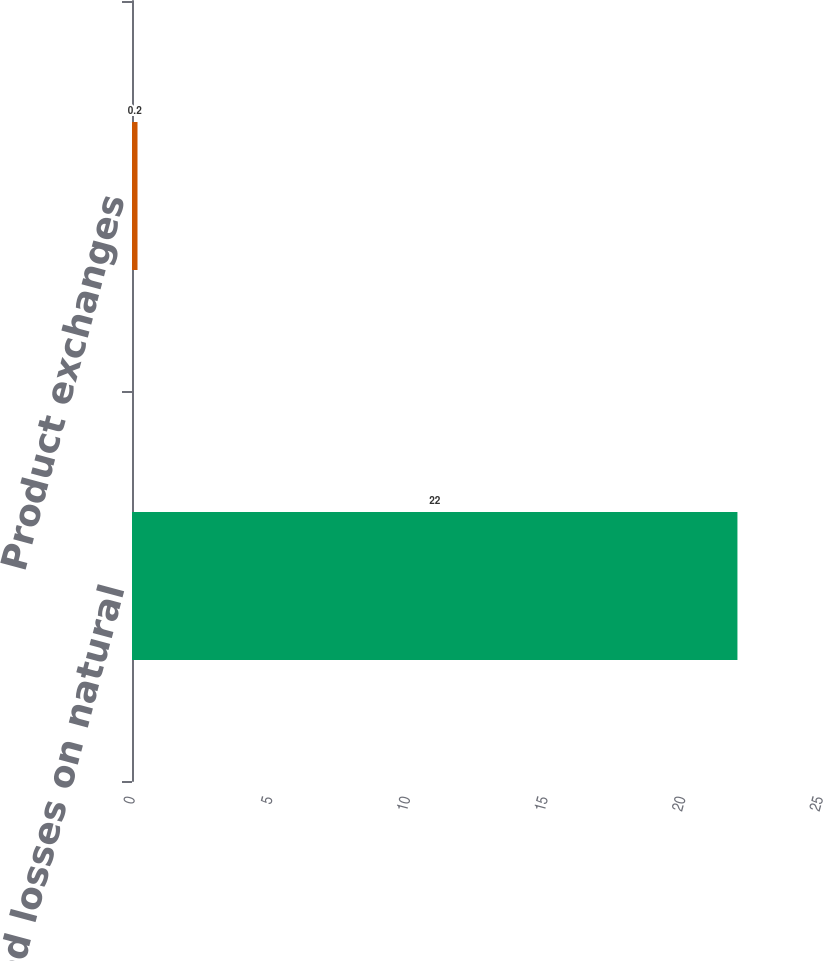<chart> <loc_0><loc_0><loc_500><loc_500><bar_chart><fcel>Unrealized losses on natural<fcel>Product exchanges<nl><fcel>22<fcel>0.2<nl></chart> 